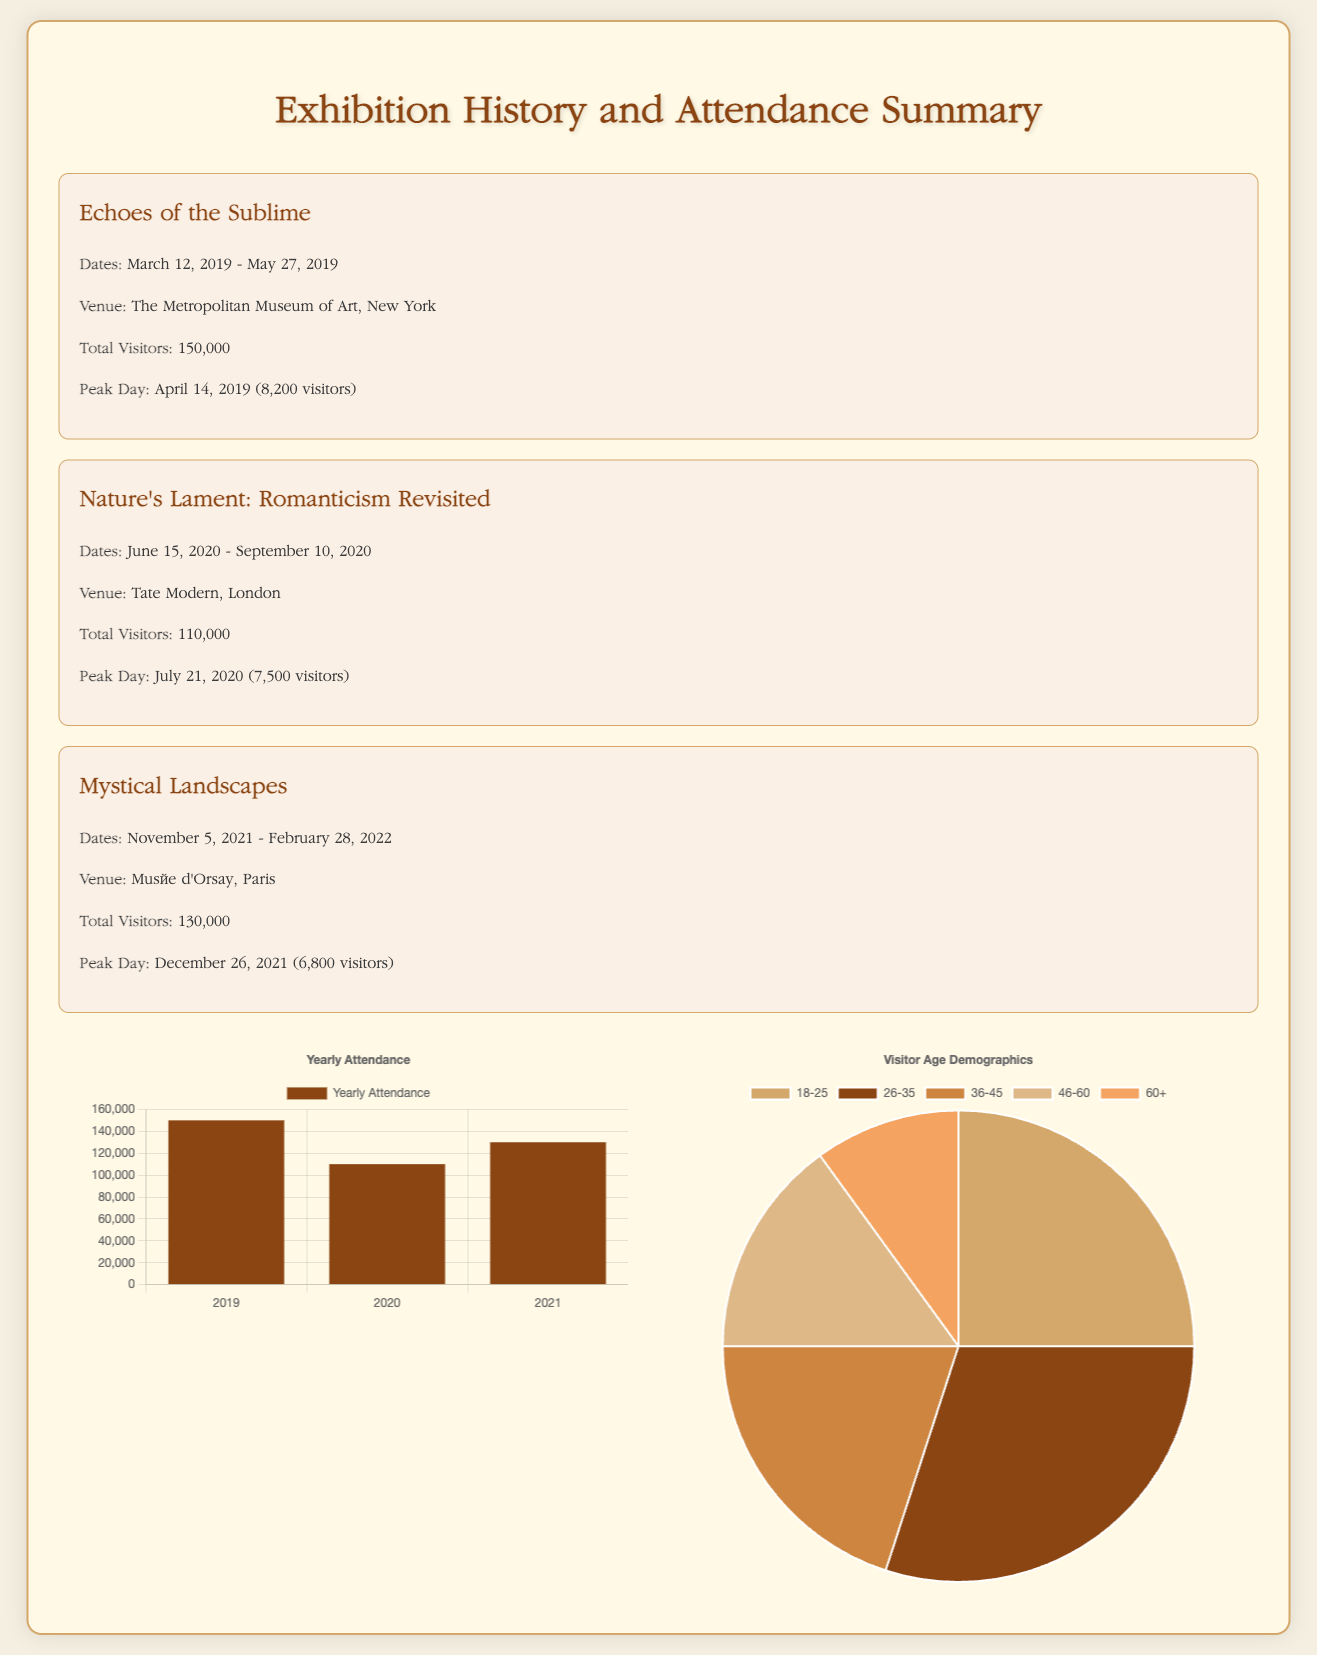What was the title of the first exhibition? The title of the first exhibition listed in the document is the first entry in the Exhibitions section.
Answer: Echoes of the Sublime How many total visitors attended the exhibition at Tate Modern? The total visitors for the exhibition at Tate Modern is stated in the VisitorStatistics for that exhibition.
Answer: 110000 When did the Mystical Landscapes exhibition take place? The dates for the Mystical Landscapes exhibition are given directly in the Exhibitions section.
Answer: November 5, 2021 - February 28, 2022 What was the peak attendance day for the Echoes of the Sublime exhibition? The peak attendance day is listed under VisitorStatistics for the same exhibition.
Answer: April 14, 2019 What percentage of visitors were female across all exhibitions? The document provides visitor demographics, specifically the percentage for gender in the VisitorDemographics section.
Answer: 55 Which year had the highest total visitor count? The yearly attendance data is presented in the VisitorDistributionByYear section, allowing determination of which year had the highest visitor count.
Answer: 2019 How many age groups are represented in the demographics chart? The age groups are listed in the VisitorDemographics section of the document, indicating how many specific categories there are.
Answer: 5 What was the total visitor count for the exhibition at Musée d'Orsay? The total visitor count is found in the VisitorStatistics for the exhibition held at Musée d'Orsay.
Answer: 130000 What chart types are used in this document? The question addresses the format and the type of visual representation found in the document.
Answer: Bar chart and pie chart 